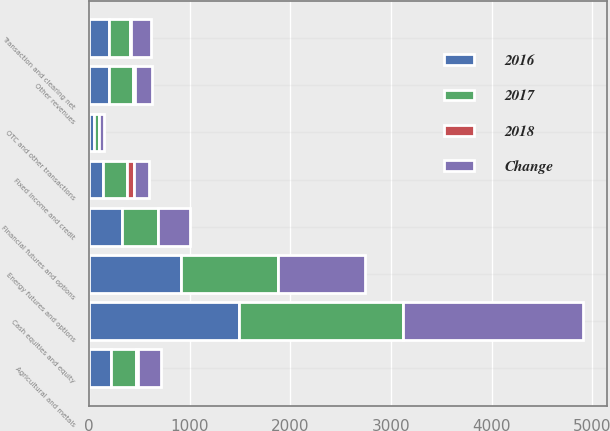Convert chart to OTSL. <chart><loc_0><loc_0><loc_500><loc_500><stacked_bar_chart><ecel><fcel>Energy futures and options<fcel>Agricultural and metals<fcel>Financial futures and options<fcel>Cash equities and equity<fcel>Fixed income and credit<fcel>OTC and other transactions<fcel>Transaction and clearing net<fcel>Other revenues<nl><fcel>2017<fcel>965<fcel>251<fcel>354<fcel>1624<fcel>240<fcel>49<fcel>202<fcel>234<nl><fcel>2016<fcel>909<fcel>216<fcel>326<fcel>1491<fcel>139<fcel>50<fcel>202<fcel>202<nl><fcel>2018<fcel>6<fcel>16<fcel>9<fcel>9<fcel>72<fcel>2<fcel>11<fcel>16<nl><fcel>Change<fcel>865<fcel>228<fcel>318<fcel>1780<fcel>143<fcel>50<fcel>202<fcel>177<nl></chart> 